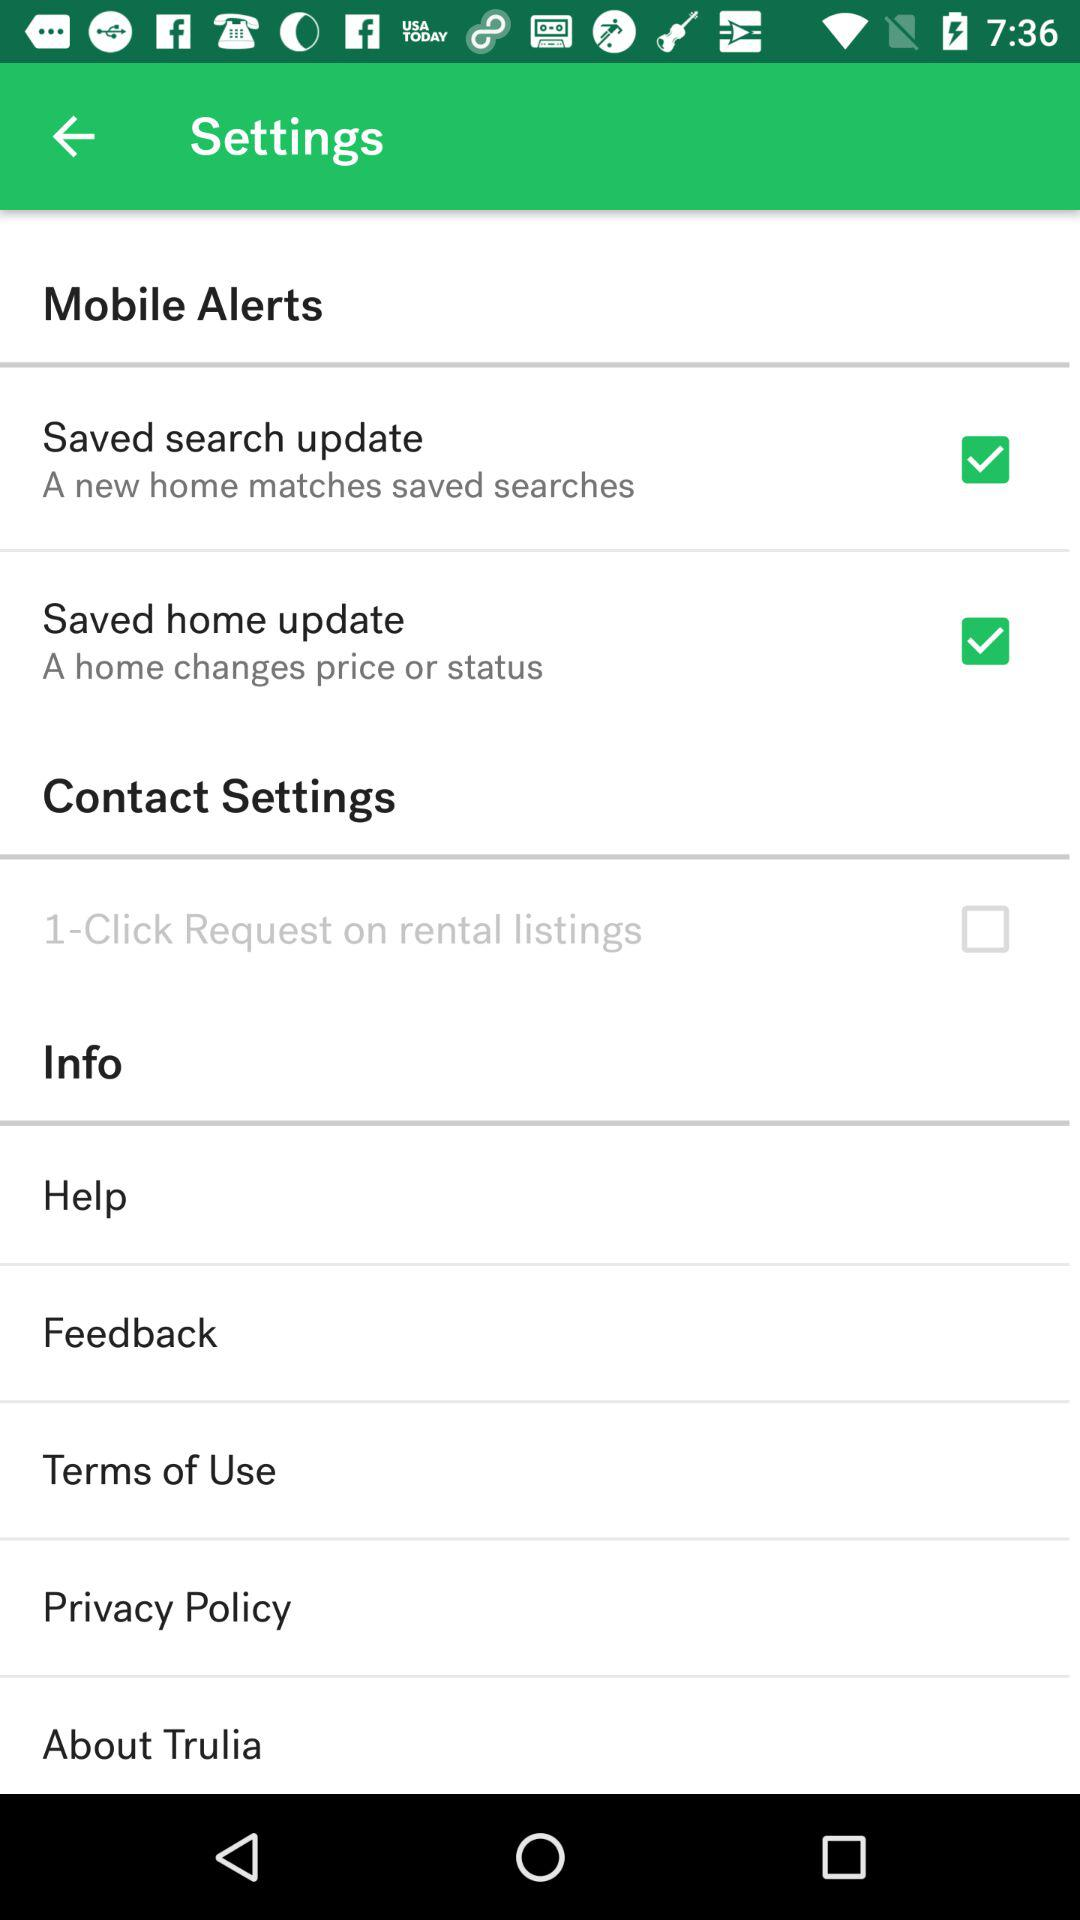What is the status of "1-Click Request on rental listings"? The status of "1-Click Request on rental listings" is "off". 